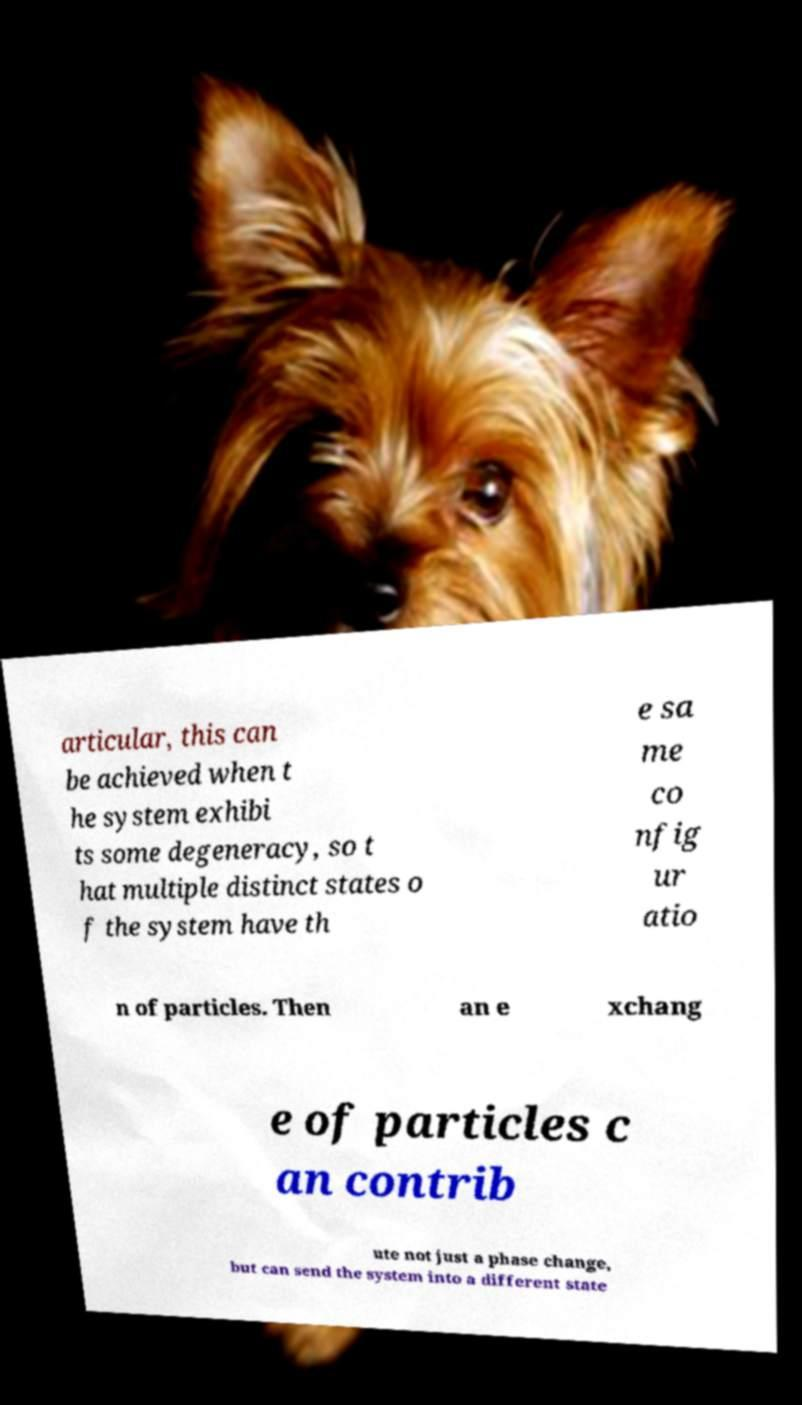For documentation purposes, I need the text within this image transcribed. Could you provide that? articular, this can be achieved when t he system exhibi ts some degeneracy, so t hat multiple distinct states o f the system have th e sa me co nfig ur atio n of particles. Then an e xchang e of particles c an contrib ute not just a phase change, but can send the system into a different state 